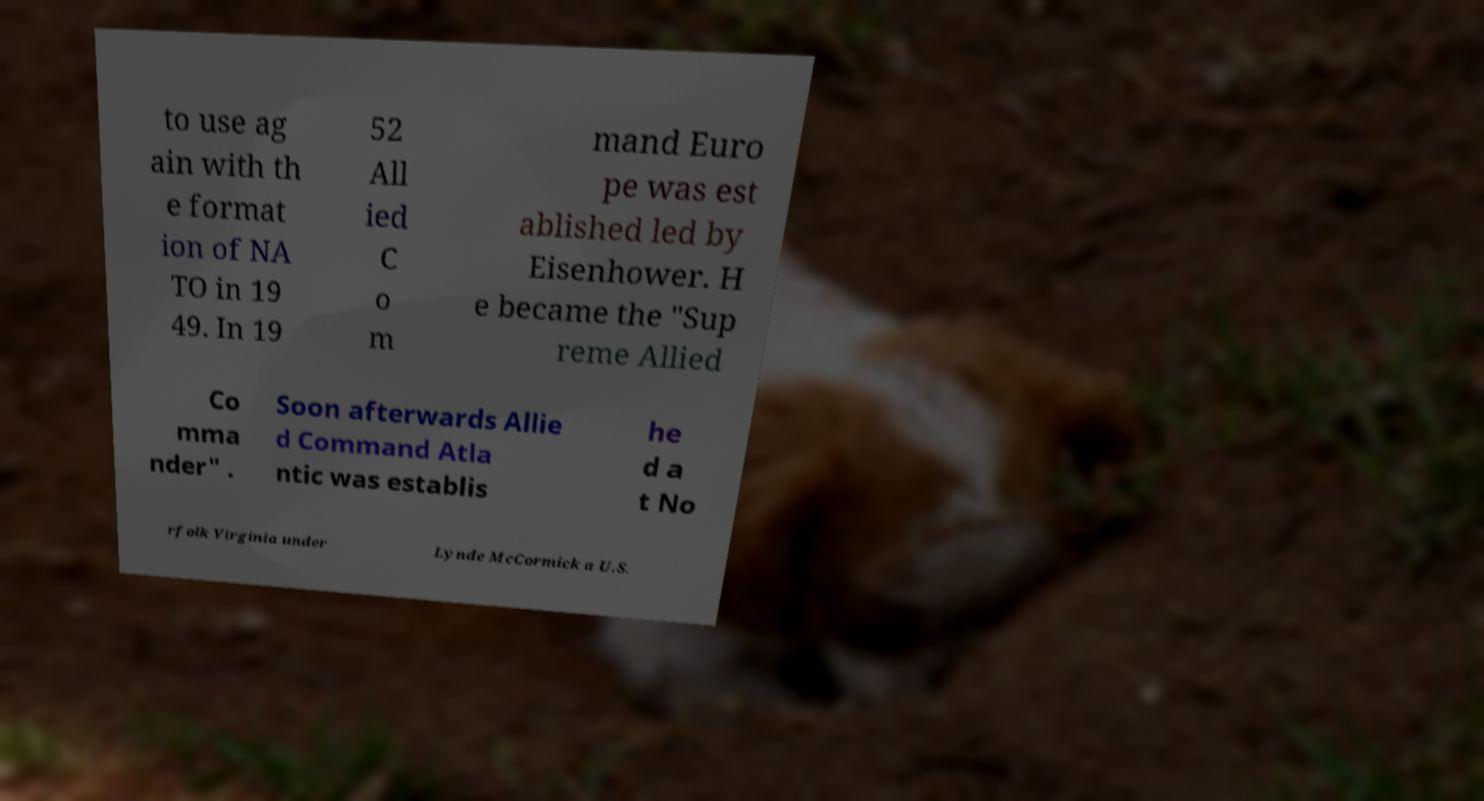Please read and relay the text visible in this image. What does it say? to use ag ain with th e format ion of NA TO in 19 49. In 19 52 All ied C o m mand Euro pe was est ablished led by Eisenhower. H e became the "Sup reme Allied Co mma nder" . Soon afterwards Allie d Command Atla ntic was establis he d a t No rfolk Virginia under Lynde McCormick a U.S. 